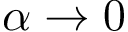Convert formula to latex. <formula><loc_0><loc_0><loc_500><loc_500>\alpha \rightarrow 0</formula> 